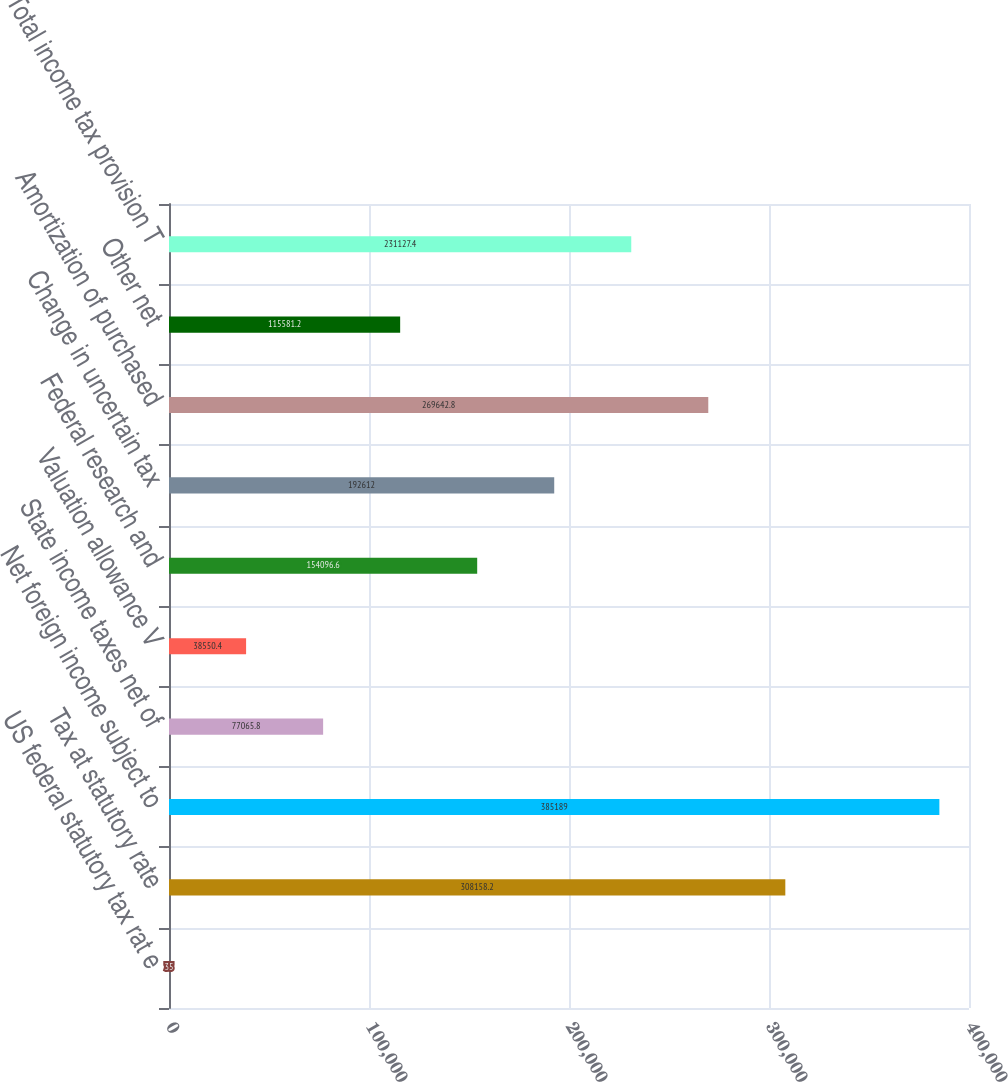<chart> <loc_0><loc_0><loc_500><loc_500><bar_chart><fcel>US federal statutory tax rat e<fcel>Tax at statutory rate<fcel>Net foreign income subject to<fcel>State income taxes net of<fcel>Valuation allowance V<fcel>Federal research and<fcel>Change in uncertain tax<fcel>Amortization of purchased<fcel>Other net<fcel>Total income tax provision T<nl><fcel>35<fcel>308158<fcel>385189<fcel>77065.8<fcel>38550.4<fcel>154097<fcel>192612<fcel>269643<fcel>115581<fcel>231127<nl></chart> 